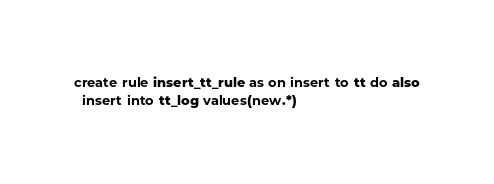<code> <loc_0><loc_0><loc_500><loc_500><_SQL_>create rule insert_tt_rule as on insert to tt do also
  insert into tt_log values(new.*)
</code> 